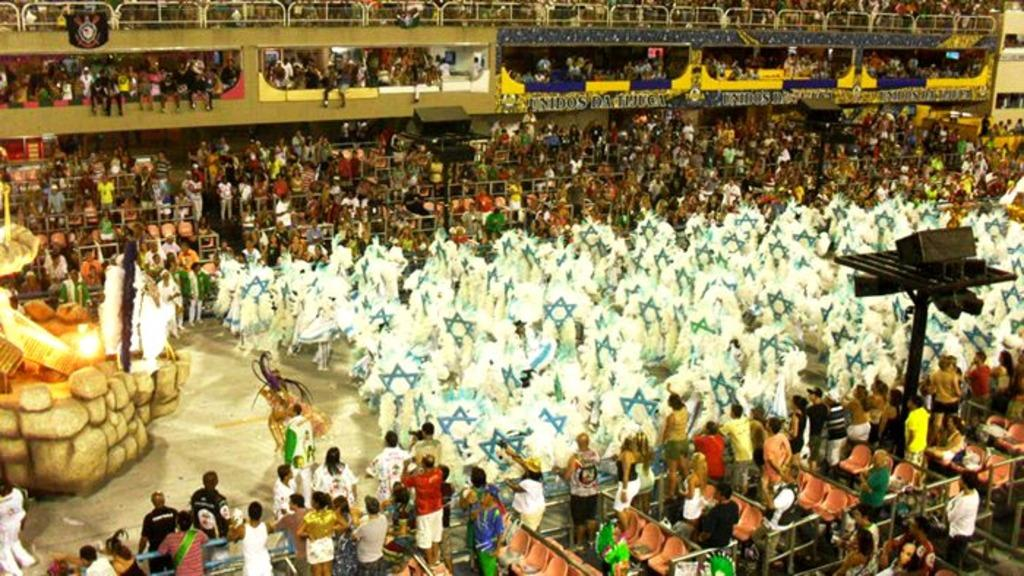What is happening in the image involving the group of people? The people in the image are standing and observing. Can you describe the position of the light in the image? There is a light on the left side of the image. What type of prison can be seen in the background of the image? There is no prison visible in the image; it only features a group of people standing and observing, and a light on the left side. 